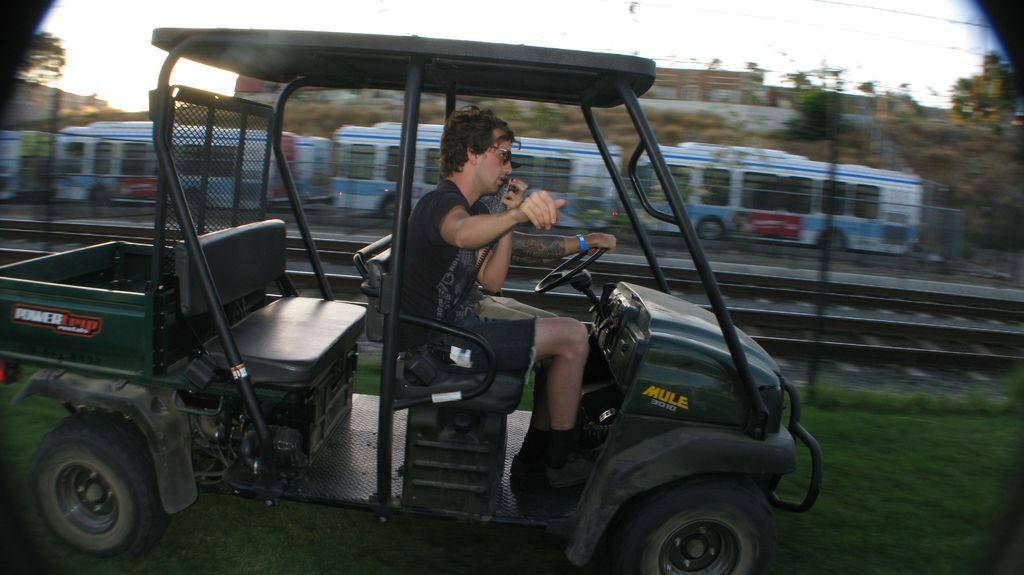What is the main subject of the image? There is a person in a vehicle in the image. What else can be seen in the image besides the vehicle? There is a train on the track in the image. What type of natural environment is visible in the image? There are trees around in the image. How many kittens are sitting on the train in the image? There are no kittens present in the image; it features a person in a vehicle and a train on the track. What type of cars are parked near the trees in the image? There are no cars present in the image; it features a person in a vehicle, a train on the track, and trees in the natural environment. 